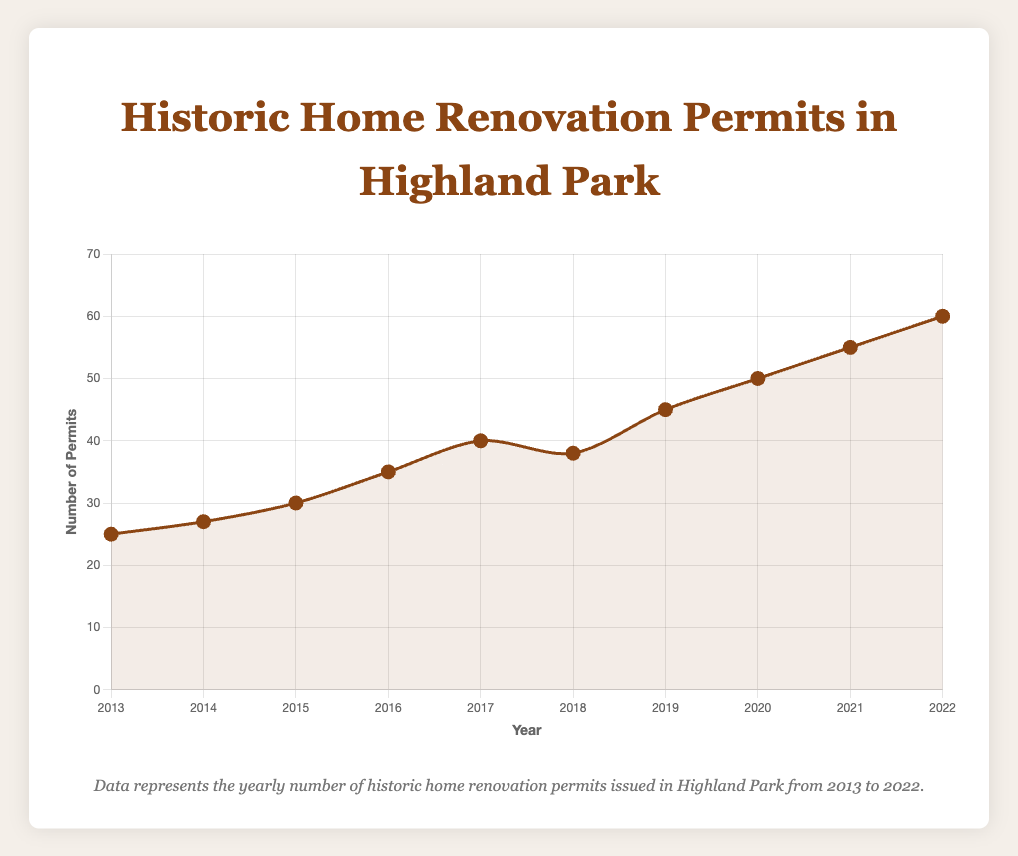What is the trend in the number of historic home renovation permits issued from 2013 to 2022? The line plot demonstrates a general upward trend in the number of permits issued from 2013 (25 permits) to 2022 (60 permits). Although there is a slight dip in 2018, the overall trend is an increase.
Answer: Upward trend How many more permits were issued in 2022 compared to 2013? In 2022, there were 60 permits issued, while in 2013, there were 25 permits. The difference is 60 - 25 = 35 permits.
Answer: 35 permits Which year saw the highest number of historic home renovation permits issued? By observing the highest point on the line plot, 2022 had the highest number of permits issued, with 60 permits.
Answer: 2022 What is the average number of permits issued per year from 2013 to 2022? To find the average, sum the permits for each year (25 + 27 + 30 + 35 + 40 + 38 + 45 + 50 + 55 + 60) which equals 405, and then divide by the number of years (10). The average is 405/10 = 40.5 permits per year.
Answer: 40.5 permits In which year was there a decrease in the number of permits issued compared to the previous year? The number of permits issued in 2018 (38) was less than that in 2017 (40). This is the only year showing a decrease.
Answer: 2018 Compare the number of permits issued in 2014 and 2019. Which year had more permits issued, and by how much? In 2014, there were 27 permits issued, and in 2019, there were 45 permits issued. The difference is 45 - 27 = 18 permits, with 2019 having more.
Answer: 2019 by 18 permits What is the growth rate in the number of permits issued from 2013 to 2022? The growth rate can be found using the formula ((final value - initial value) / initial value) * 100. Here, ((60 - 25) / 25) * 100 = 140%.
Answer: 140% Which two consecutive years had the greatest increase in the number of permits issued? The largest increase is observed between 2016 (35 permits) and 2017 (40 permits), with an increase of 5 permits.
Answer: 2016 and 2017 What is the median number of permits issued over the ten years provided? First, arrange the number of permits ascendingly: 25, 27, 30, 35, 38, 40, 45, 50, 55, 60. Since there are 10 data points, the median is the average of the 5th and 6th values. So, (38 + 40)/2 = 39.
Answer: 39 What is the approximate slope of the line representing the number of permits issued from 2013 to 2022? The slope can be calculated as (change in permits) / (change in years). The change in permits is 60 - 25 = 35, and the change in years is 2022 - 2013 = 9. So, the slope = 35/9 ≈ 3.89 permits per year.
Answer: ≈3.89 permits per year 